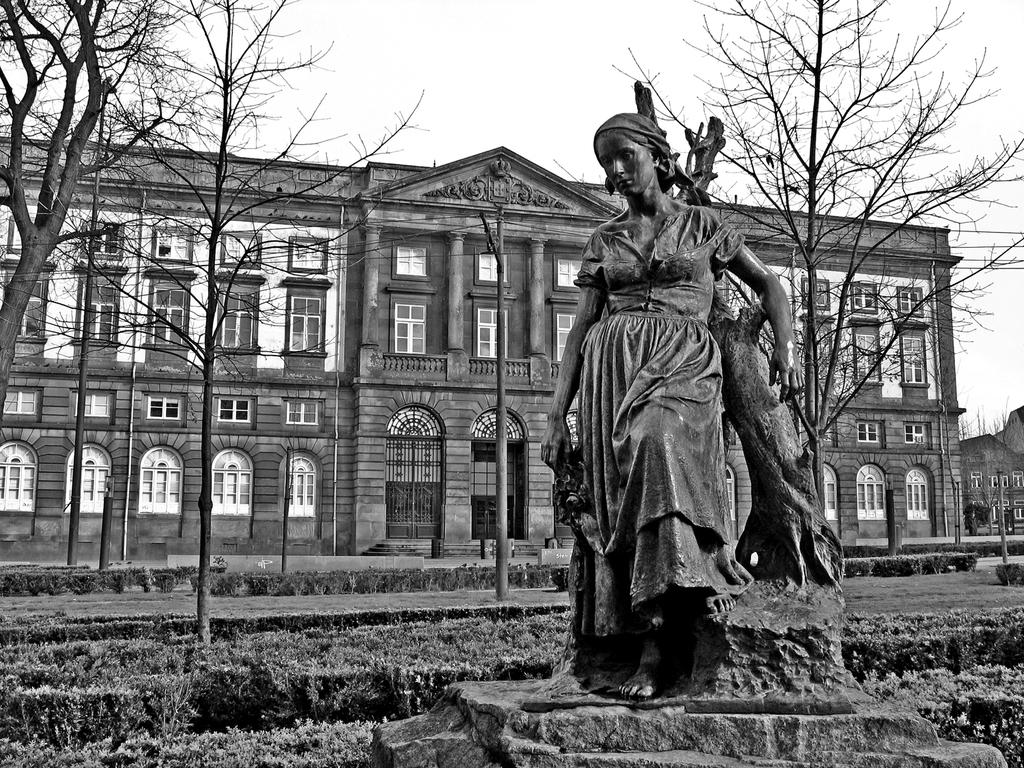What is the main subject in the foreground of the image? There is a sculpture in the foreground of the image. What type of vegetation can be seen in the image? There are plants and trees in the image. What type of man-made structures are visible in the image? There are buildings in the image. What part of the natural environment is visible in the image? The sky is visible in the image. What type of spy equipment can be seen in the image? There is no spy equipment present in the image. Can you describe the bed in the image? There is no bed present in the image. 